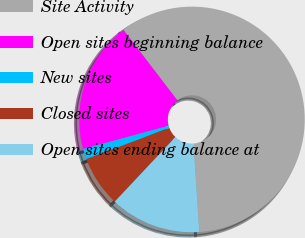<chart> <loc_0><loc_0><loc_500><loc_500><pie_chart><fcel>Site Activity<fcel>Open sites beginning balance<fcel>New sites<fcel>Closed sites<fcel>Open sites ending balance at<nl><fcel>59.36%<fcel>18.84%<fcel>1.48%<fcel>7.27%<fcel>13.05%<nl></chart> 